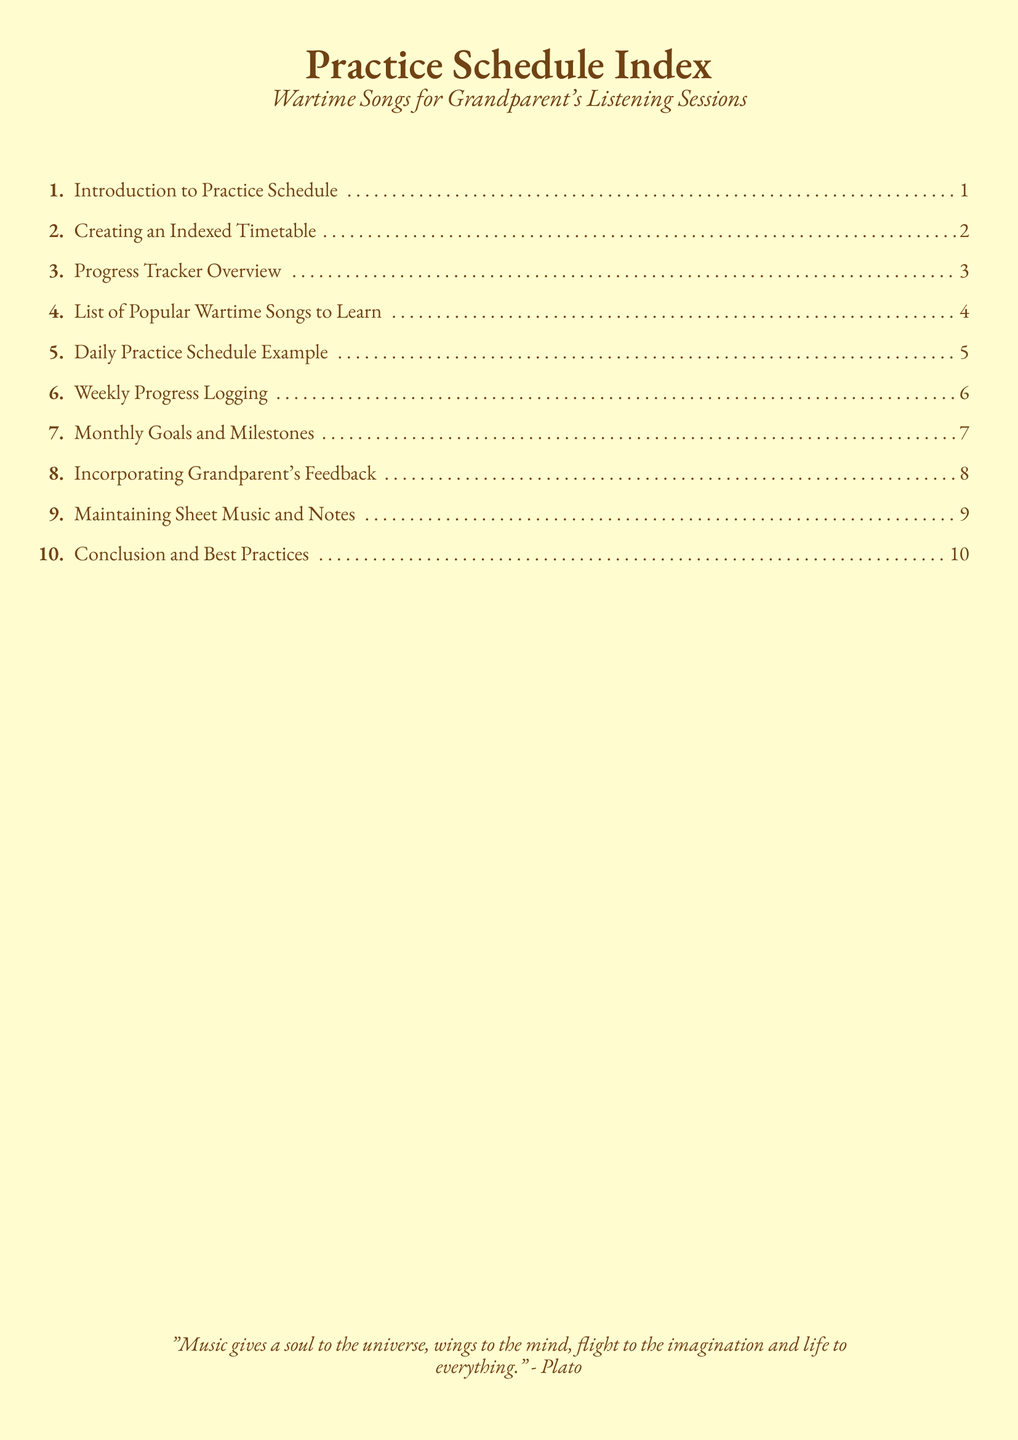What is the title of the document? The title is prominently displayed at the beginning of the document and is "Practice Schedule Index."
Answer: Practice Schedule Index How many sections are listed in the index? The index contains a total of ten sections numbered from 1 to 10.
Answer: 10 What is the focus of the practice schedule? The document specifically mentions "Wartime Songs for Grandparent's Listening Sessions" in the title.
Answer: Wartime Songs for Grandparent's Listening Sessions What is the page margin size used in the document? The document's margins are set using the geometry package, with left and right margins specified as 1cm.
Answer: 1cm Which section discusses incorporating feedback? The section that addresses feedback is clearly indicated as number 8 in the index.
Answer: Incorporating Grandparent's Feedback What does the quote at the end of the document emphasize? The quote highlights the profound impact of music, describing its effects on the universe, mind, and imagination.
Answer: Music gives a soul to the universe What type of document is this? The structure and content of the document suggest it is an index, serving as an overview for a practice schedule.
Answer: Index Which section number corresponds to the "Progress Tracker Overview"? The index item specifically detailing the progress tracker is number 3.
Answer: 3 What is the last section listed in the index? The final section in the index concludes with best practices, numbered as 10.
Answer: Conclusion and Best Practices 